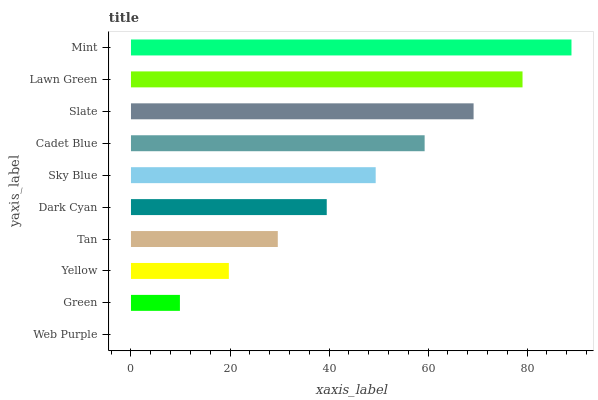Is Web Purple the minimum?
Answer yes or no. Yes. Is Mint the maximum?
Answer yes or no. Yes. Is Green the minimum?
Answer yes or no. No. Is Green the maximum?
Answer yes or no. No. Is Green greater than Web Purple?
Answer yes or no. Yes. Is Web Purple less than Green?
Answer yes or no. Yes. Is Web Purple greater than Green?
Answer yes or no. No. Is Green less than Web Purple?
Answer yes or no. No. Is Sky Blue the high median?
Answer yes or no. Yes. Is Dark Cyan the low median?
Answer yes or no. Yes. Is Green the high median?
Answer yes or no. No. Is Green the low median?
Answer yes or no. No. 